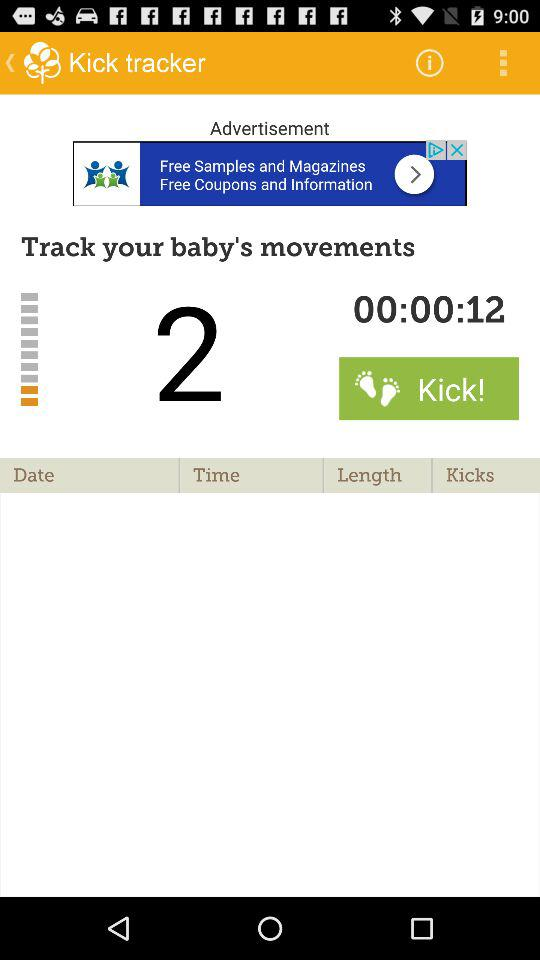What is the app name? The app name is "Kick tracker". 